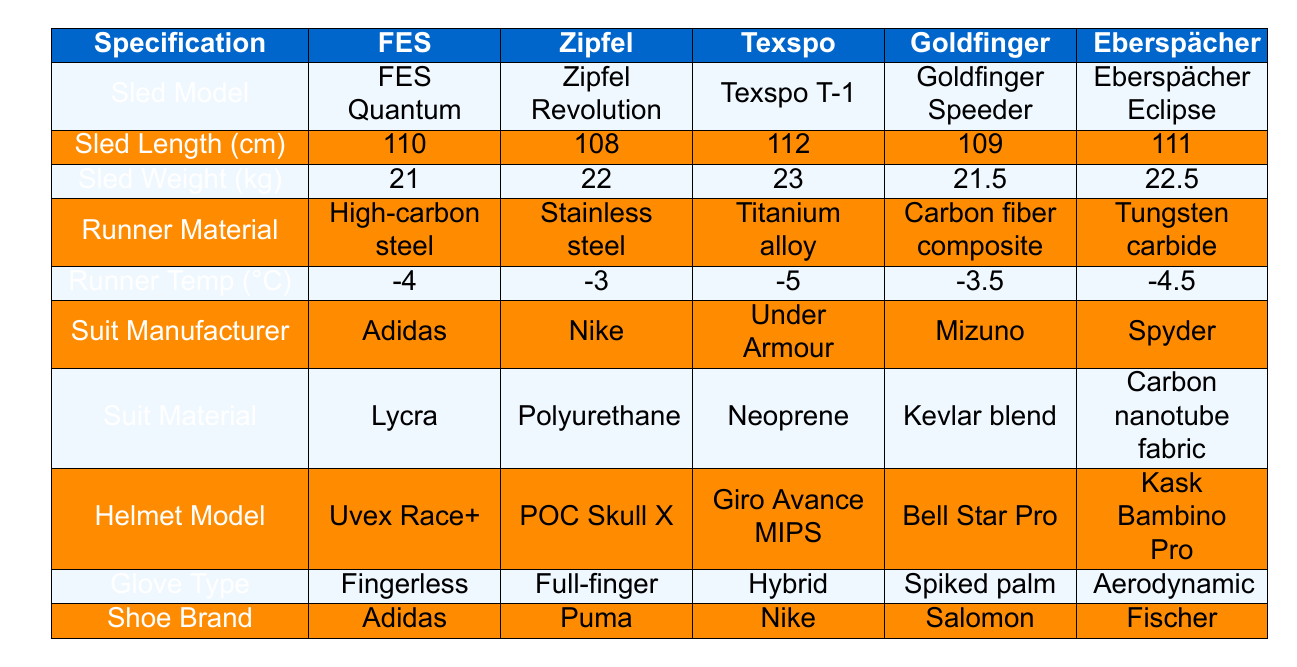What is the weight of the Goldfinger Sled? From the table, the sled weight for Goldfinger is listed as 21.5 kg.
Answer: 21.5 kg Which manufacturer produces the lightest sled? Examining the sled weights in the table, the weights are 21 kg (FES), 22 kg (Zipfel), 23 kg (Texspo), 21.5 kg (Goldfinger), and 22.5 kg (Eberspächer). The lightest is the FES sled at 21 kg.
Answer: FES What is the sled length of the Texspo model? The table states that the sled length for the Texspo T-1 model is 112 cm.
Answer: 112 cm Is the runner material for Eberspächer made of high-carbon steel? The runner material for Eberspächer is listed as tungsten carbide in the table, not high-carbon steel.
Answer: No What material is used in the suit from Under Armour? The table shows that the suit material for Under Armour is neoprene.
Answer: Neoprene What is the average sled length among the five manufacturers? The sled lengths are 110 cm, 108 cm, 112 cm, 109 cm, and 111 cm. The sum is 550 cm, divided by 5 gives an average length of 110 cm.
Answer: 110 cm Which helmet model comes from the manufacturer Giro? According to the table, the helmet model from Giro is the Giro Avance MIPS.
Answer: Giro Avance MIPS What is the difference in sled weight between the heaviest and the lightest sled? The heaviest sled is Texspo at 23 kg and the lightest is FES at 21 kg. The difference is 23 kg - 21 kg = 2 kg.
Answer: 2 kg Do Adidas suits use carbon nanotube fabric? According to the table, the suit material for Adidas is listed as Lycra, not carbon nanotube fabric.
Answer: No Which runner material is the only one made from carbon fiber composite? The table indicates that the runner material made from carbon fiber composite belongs to Goldfinger.
Answer: Goldfinger 